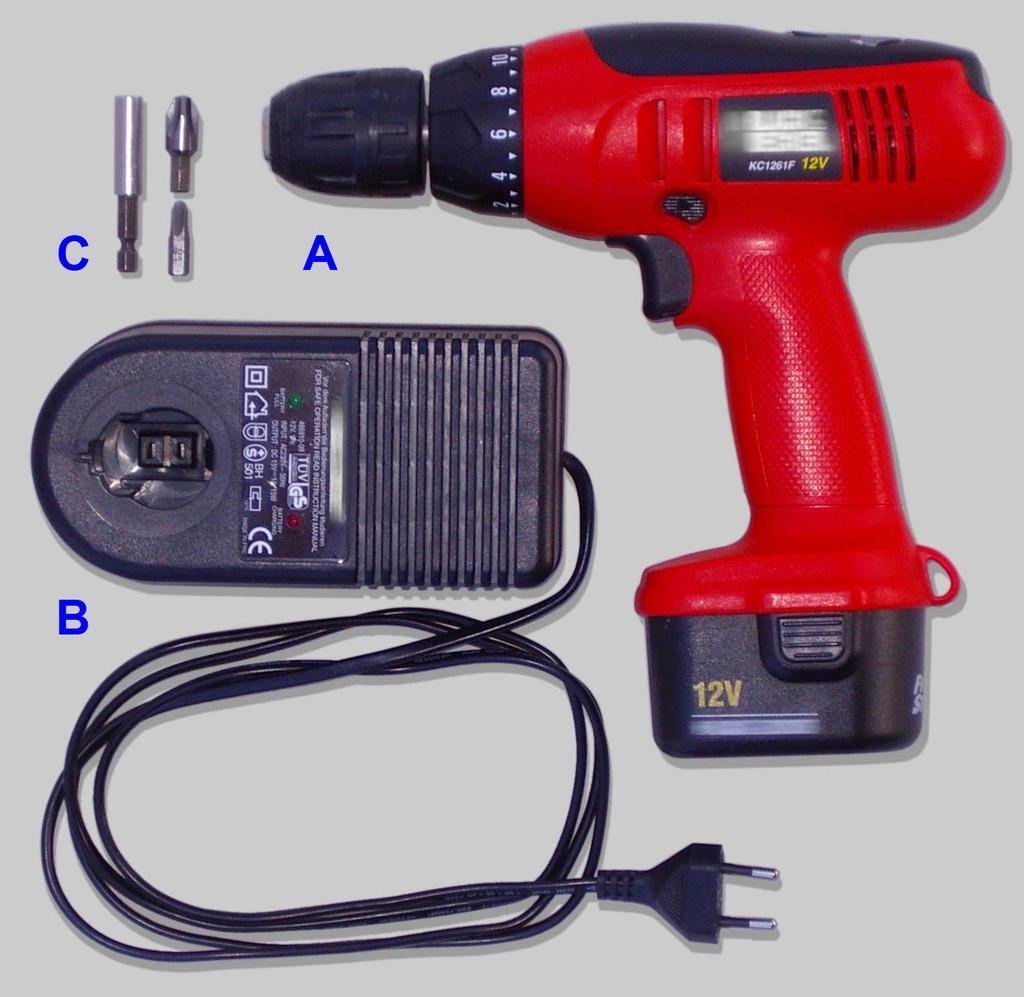Describe this image in one or two sentences. In this image there is a drilling machine and a few other objects on the white color surface. 